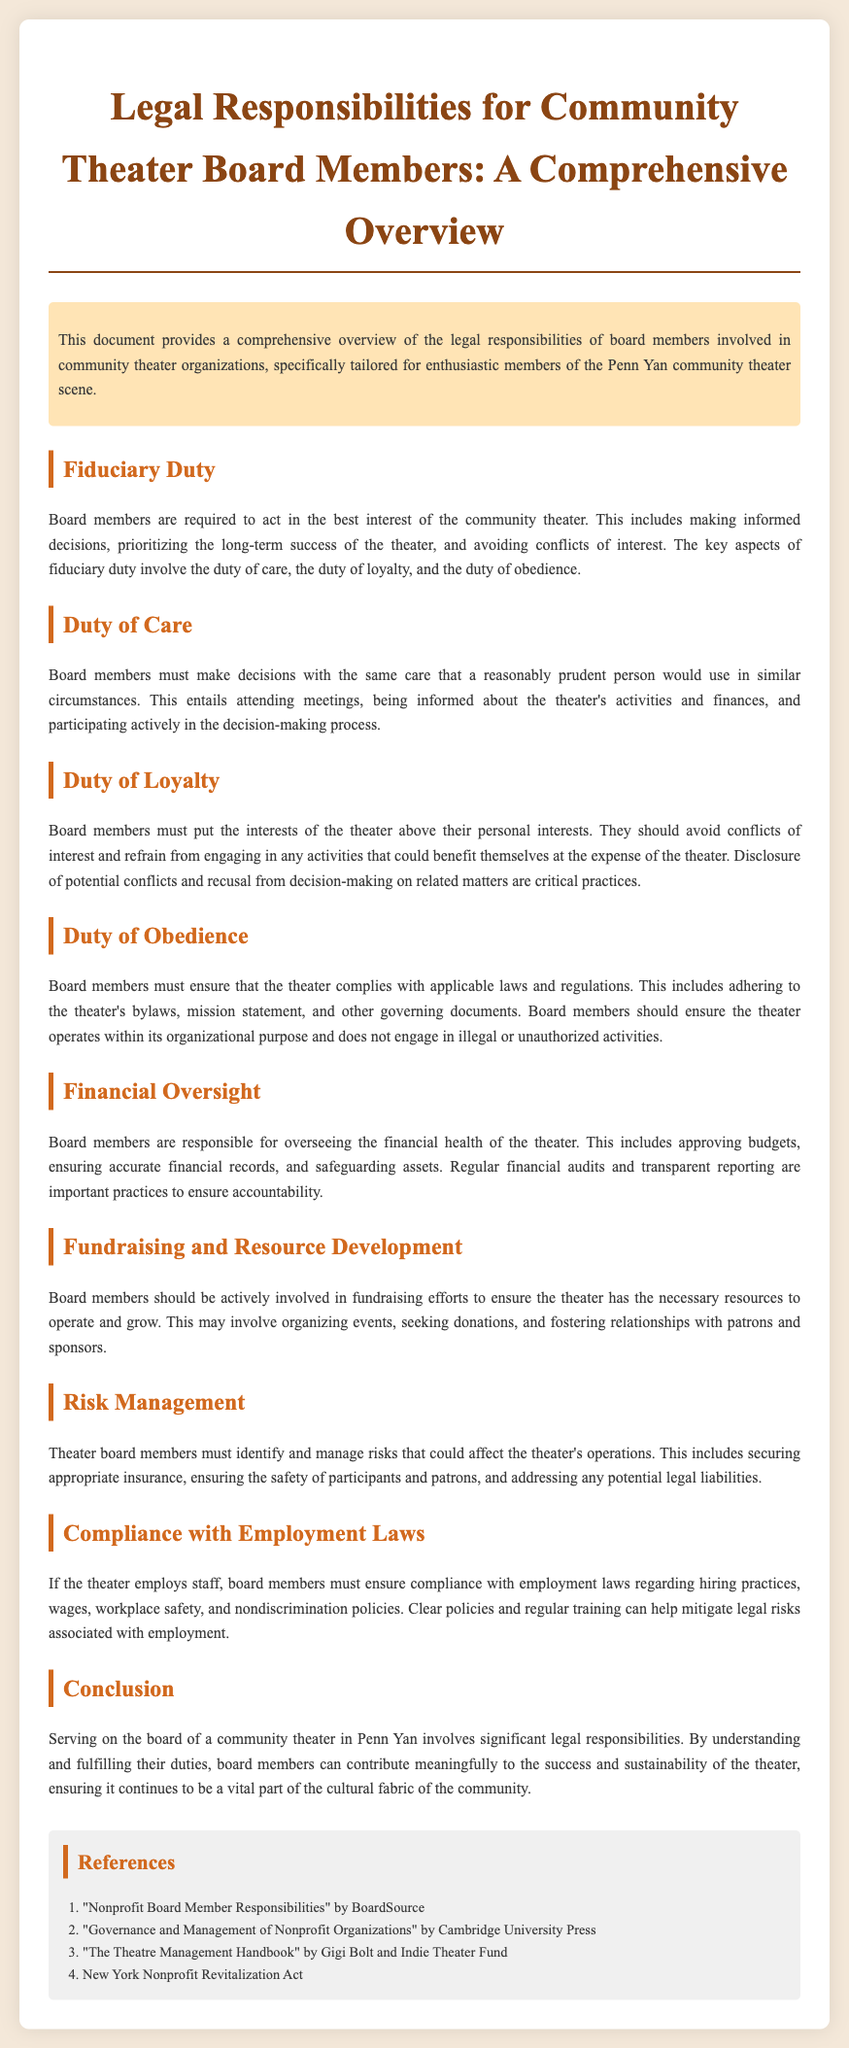What is the primary duty of board members? The primary duty of board members is to act in the best interest of the community theater.
Answer: best interest of the community theater What are the three key aspects of fiduciary duty? The three key aspects of fiduciary duty involve the duty of care, the duty of loyalty, and the duty of obedience.
Answer: duty of care, duty of loyalty, duty of obedience What must board members ensure regarding compliance? Board members must ensure that the theater complies with applicable laws and regulations.
Answer: applicable laws and regulations What is essential for financial oversight? Essential practices for financial oversight include approving budgets, ensuring accurate financial records, and safeguarding assets.
Answer: approving budgets, ensuring accurate financial records, safeguarding assets Who should board members avoid conflicts of interest with? Board members must put the interests of the theater above their personal interests.
Answer: personal interests What is one responsibility related to fundraising? One responsibility of board members related to fundraising is to organize events.
Answer: organize events Which law must board members comply with regarding employment? Board members must ensure compliance with employment laws.
Answer: employment laws What does risk management involve? Risk management involves identifying and managing risks that could affect the theater's operations.
Answer: identifying and managing risks What does the document primarily summarize? The document primarily summarizes the legal responsibilities of board members involved in community theater organizations.
Answer: legal responsibilities of board members 